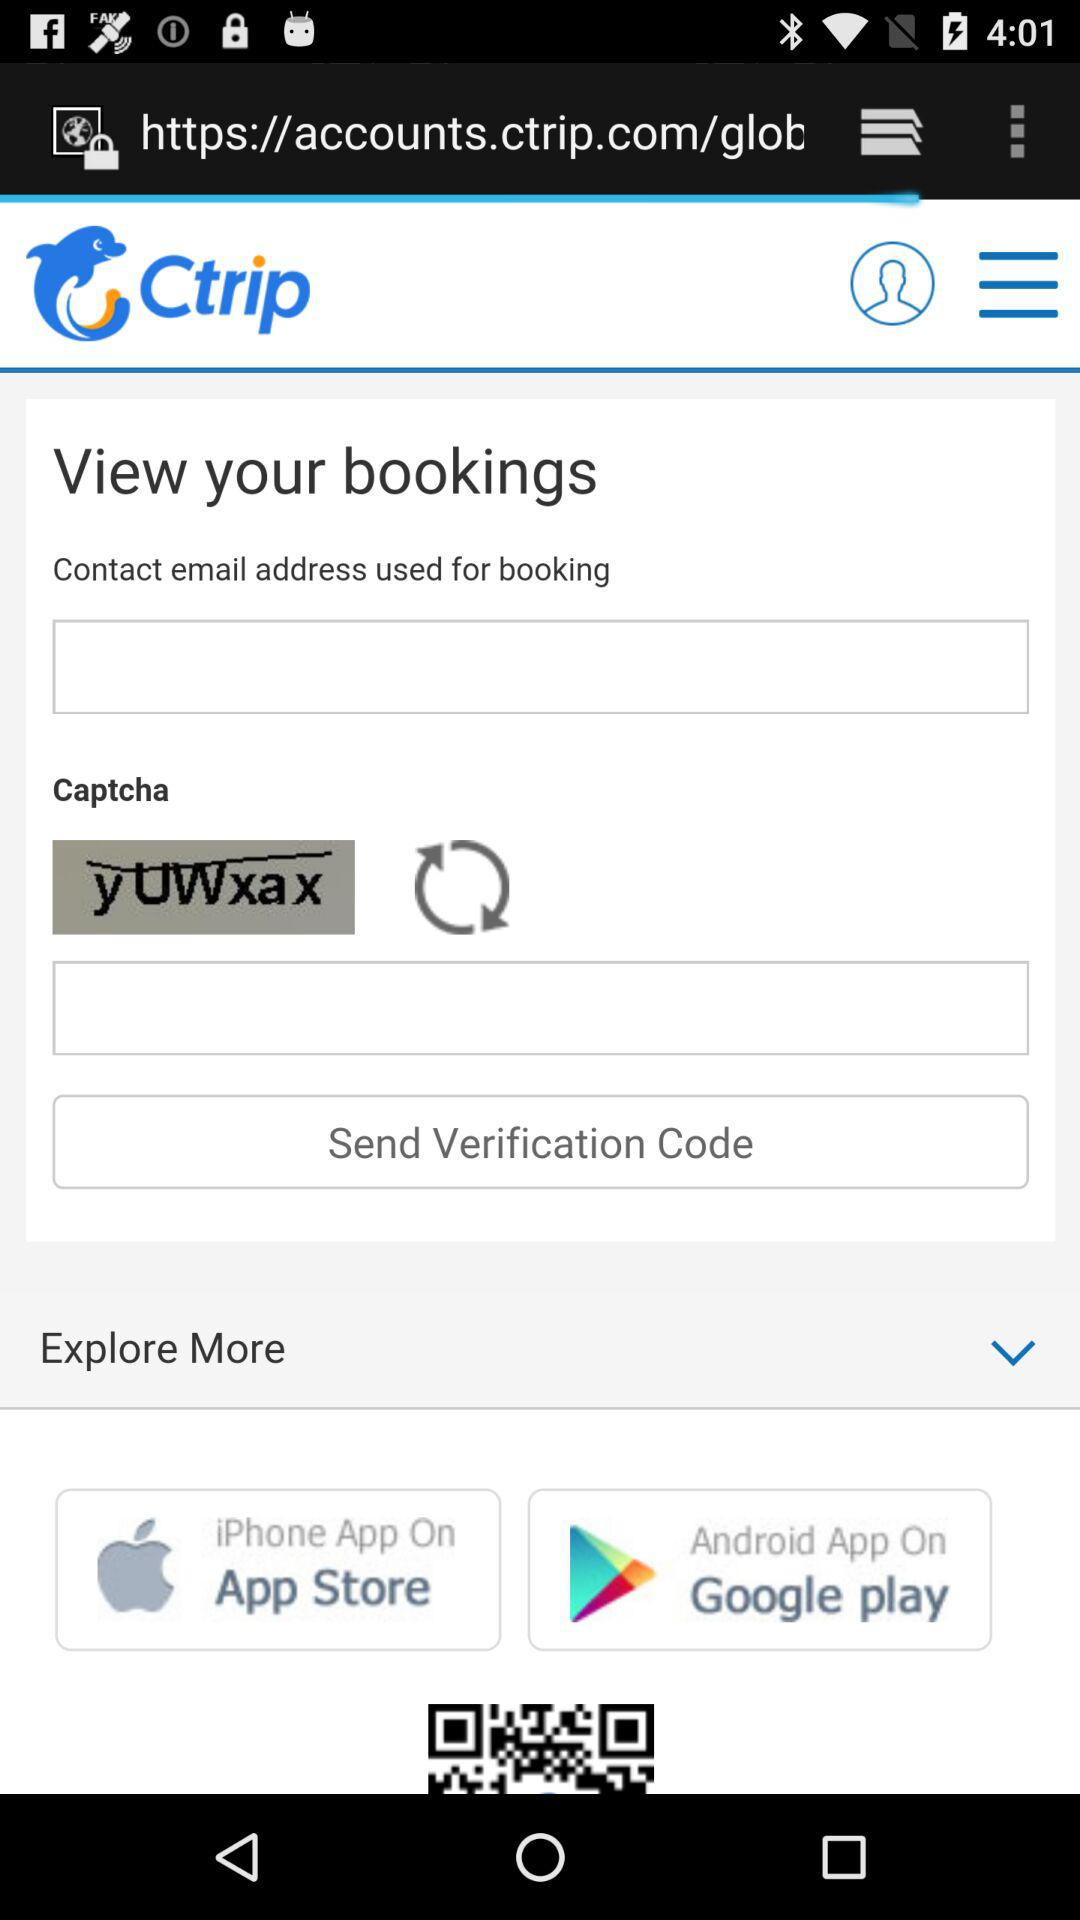How many fields are required to submit the form?
Answer the question using a single word or phrase. 3 